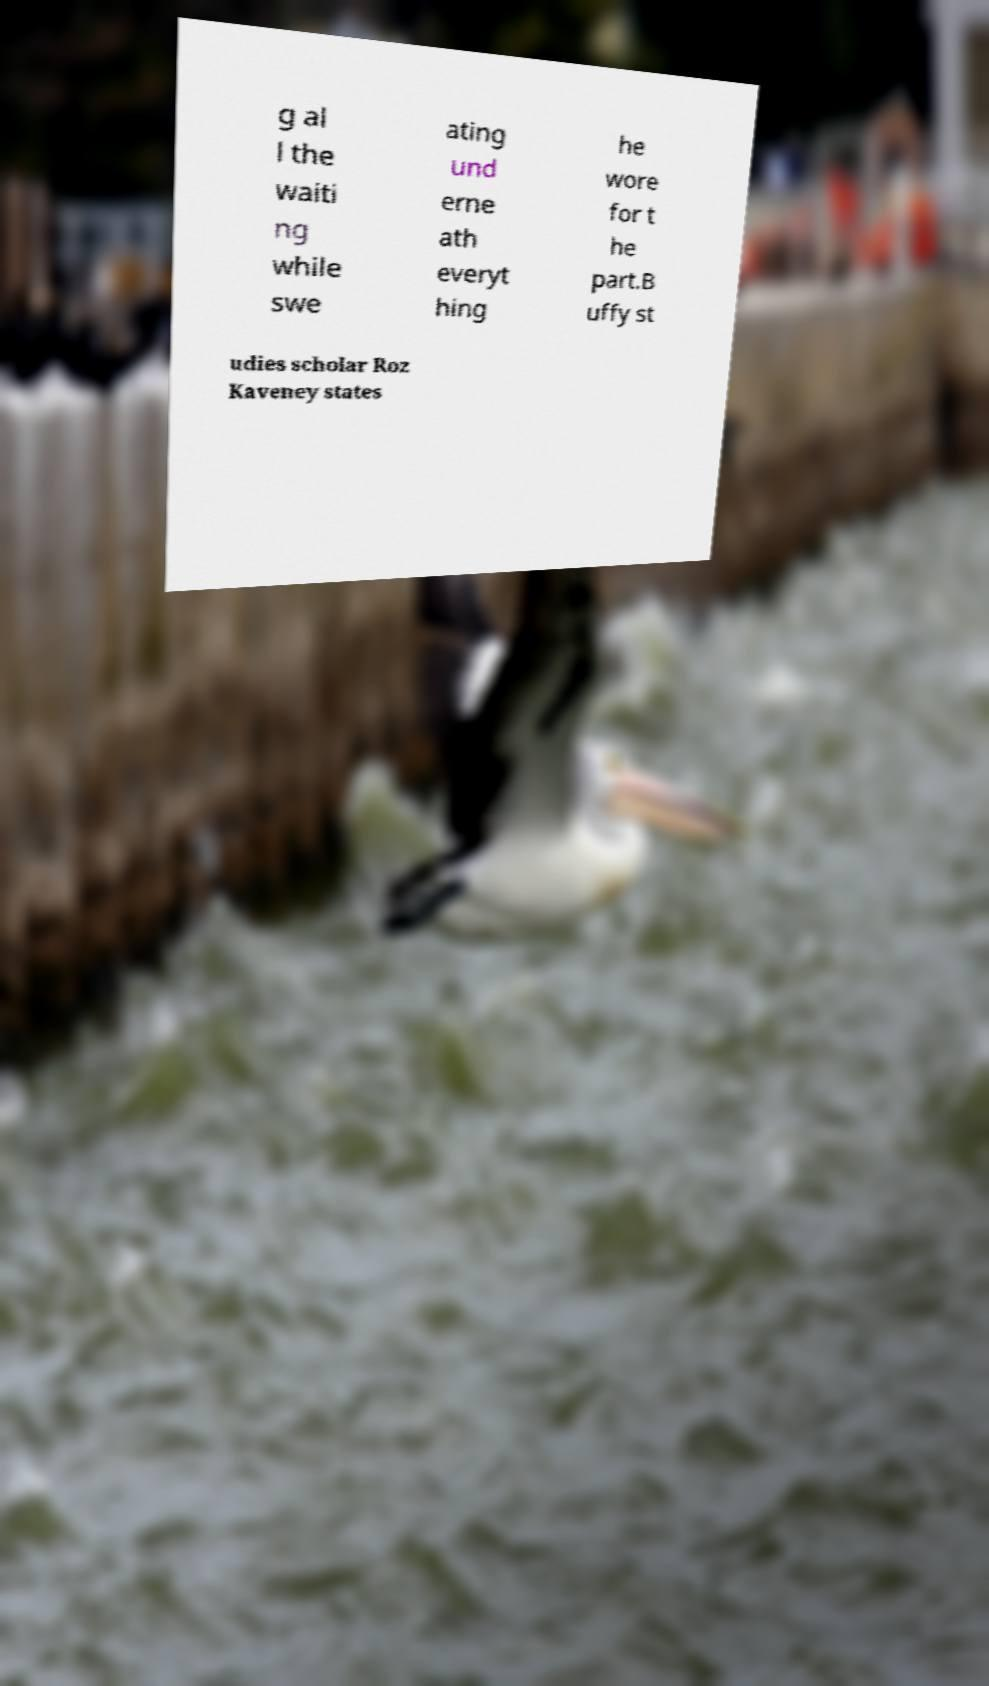For documentation purposes, I need the text within this image transcribed. Could you provide that? g al l the waiti ng while swe ating und erne ath everyt hing he wore for t he part.B uffy st udies scholar Roz Kaveney states 